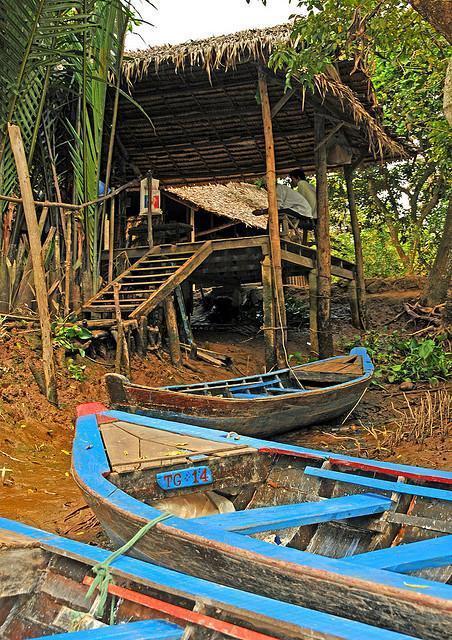How many boats are there?
Give a very brief answer. 3. How many kites are in this picture?
Give a very brief answer. 0. 